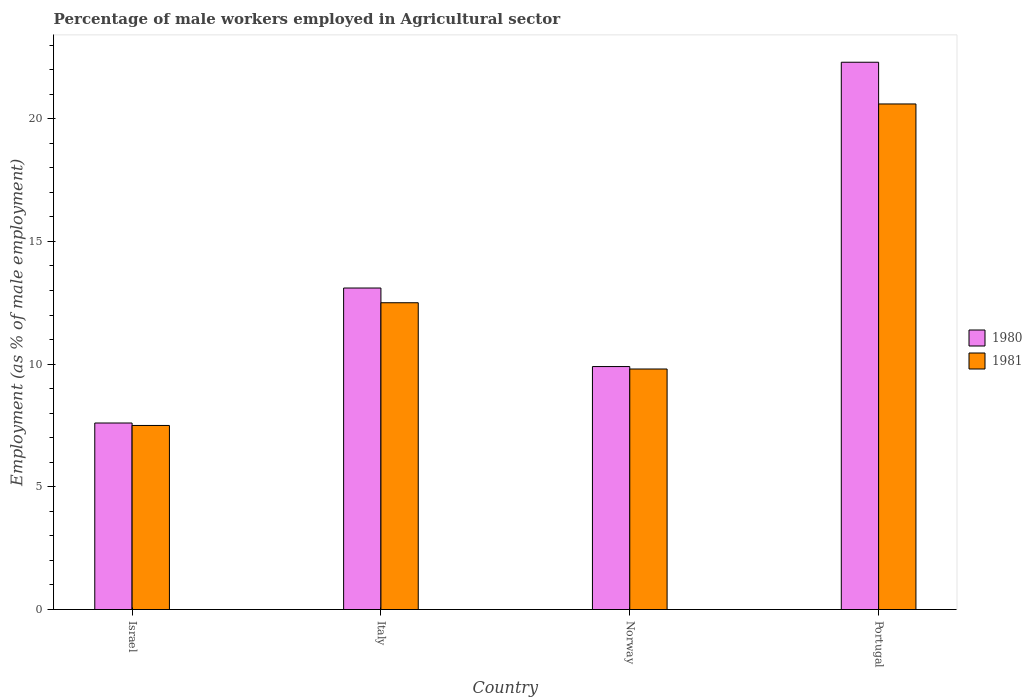How many different coloured bars are there?
Your answer should be very brief. 2. Are the number of bars per tick equal to the number of legend labels?
Provide a succinct answer. Yes. Are the number of bars on each tick of the X-axis equal?
Your response must be concise. Yes. How many bars are there on the 3rd tick from the right?
Make the answer very short. 2. In how many cases, is the number of bars for a given country not equal to the number of legend labels?
Offer a very short reply. 0. What is the percentage of male workers employed in Agricultural sector in 1980 in Norway?
Your answer should be very brief. 9.9. Across all countries, what is the maximum percentage of male workers employed in Agricultural sector in 1980?
Give a very brief answer. 22.3. In which country was the percentage of male workers employed in Agricultural sector in 1981 minimum?
Keep it short and to the point. Israel. What is the total percentage of male workers employed in Agricultural sector in 1980 in the graph?
Your answer should be compact. 52.9. What is the difference between the percentage of male workers employed in Agricultural sector in 1981 in Italy and that in Portugal?
Ensure brevity in your answer.  -8.1. What is the difference between the percentage of male workers employed in Agricultural sector in 1981 in Portugal and the percentage of male workers employed in Agricultural sector in 1980 in Norway?
Provide a succinct answer. 10.7. What is the average percentage of male workers employed in Agricultural sector in 1981 per country?
Give a very brief answer. 12.6. What is the difference between the percentage of male workers employed in Agricultural sector of/in 1981 and percentage of male workers employed in Agricultural sector of/in 1980 in Norway?
Offer a terse response. -0.1. What is the ratio of the percentage of male workers employed in Agricultural sector in 1980 in Norway to that in Portugal?
Ensure brevity in your answer.  0.44. What is the difference between the highest and the second highest percentage of male workers employed in Agricultural sector in 1981?
Provide a succinct answer. -10.8. What is the difference between the highest and the lowest percentage of male workers employed in Agricultural sector in 1980?
Your response must be concise. 14.7. What does the 1st bar from the left in Israel represents?
Keep it short and to the point. 1980. Are all the bars in the graph horizontal?
Your response must be concise. No. How many countries are there in the graph?
Provide a short and direct response. 4. Are the values on the major ticks of Y-axis written in scientific E-notation?
Offer a terse response. No. Does the graph contain any zero values?
Keep it short and to the point. No. Does the graph contain grids?
Your answer should be very brief. No. Where does the legend appear in the graph?
Your answer should be very brief. Center right. How many legend labels are there?
Ensure brevity in your answer.  2. What is the title of the graph?
Offer a very short reply. Percentage of male workers employed in Agricultural sector. Does "1978" appear as one of the legend labels in the graph?
Your response must be concise. No. What is the label or title of the Y-axis?
Your response must be concise. Employment (as % of male employment). What is the Employment (as % of male employment) in 1980 in Israel?
Offer a terse response. 7.6. What is the Employment (as % of male employment) of 1981 in Israel?
Offer a terse response. 7.5. What is the Employment (as % of male employment) of 1980 in Italy?
Give a very brief answer. 13.1. What is the Employment (as % of male employment) in 1980 in Norway?
Provide a succinct answer. 9.9. What is the Employment (as % of male employment) of 1981 in Norway?
Your response must be concise. 9.8. What is the Employment (as % of male employment) of 1980 in Portugal?
Your answer should be very brief. 22.3. What is the Employment (as % of male employment) of 1981 in Portugal?
Offer a terse response. 20.6. Across all countries, what is the maximum Employment (as % of male employment) in 1980?
Ensure brevity in your answer.  22.3. Across all countries, what is the maximum Employment (as % of male employment) in 1981?
Your answer should be very brief. 20.6. Across all countries, what is the minimum Employment (as % of male employment) of 1980?
Keep it short and to the point. 7.6. Across all countries, what is the minimum Employment (as % of male employment) of 1981?
Your answer should be very brief. 7.5. What is the total Employment (as % of male employment) of 1980 in the graph?
Your response must be concise. 52.9. What is the total Employment (as % of male employment) in 1981 in the graph?
Give a very brief answer. 50.4. What is the difference between the Employment (as % of male employment) in 1980 in Israel and that in Italy?
Provide a succinct answer. -5.5. What is the difference between the Employment (as % of male employment) of 1981 in Israel and that in Norway?
Provide a short and direct response. -2.3. What is the difference between the Employment (as % of male employment) of 1980 in Israel and that in Portugal?
Provide a short and direct response. -14.7. What is the difference between the Employment (as % of male employment) in 1981 in Italy and that in Norway?
Your answer should be compact. 2.7. What is the difference between the Employment (as % of male employment) of 1980 in Norway and that in Portugal?
Provide a succinct answer. -12.4. What is the difference between the Employment (as % of male employment) of 1981 in Norway and that in Portugal?
Keep it short and to the point. -10.8. What is the difference between the Employment (as % of male employment) in 1980 in Israel and the Employment (as % of male employment) in 1981 in Italy?
Make the answer very short. -4.9. What is the difference between the Employment (as % of male employment) in 1980 in Italy and the Employment (as % of male employment) in 1981 in Norway?
Give a very brief answer. 3.3. What is the difference between the Employment (as % of male employment) of 1980 in Norway and the Employment (as % of male employment) of 1981 in Portugal?
Offer a very short reply. -10.7. What is the average Employment (as % of male employment) of 1980 per country?
Your answer should be very brief. 13.22. What is the difference between the Employment (as % of male employment) in 1980 and Employment (as % of male employment) in 1981 in Italy?
Make the answer very short. 0.6. What is the difference between the Employment (as % of male employment) in 1980 and Employment (as % of male employment) in 1981 in Norway?
Your answer should be compact. 0.1. What is the difference between the Employment (as % of male employment) of 1980 and Employment (as % of male employment) of 1981 in Portugal?
Your answer should be very brief. 1.7. What is the ratio of the Employment (as % of male employment) of 1980 in Israel to that in Italy?
Provide a succinct answer. 0.58. What is the ratio of the Employment (as % of male employment) of 1981 in Israel to that in Italy?
Offer a terse response. 0.6. What is the ratio of the Employment (as % of male employment) in 1980 in Israel to that in Norway?
Your answer should be compact. 0.77. What is the ratio of the Employment (as % of male employment) of 1981 in Israel to that in Norway?
Offer a terse response. 0.77. What is the ratio of the Employment (as % of male employment) in 1980 in Israel to that in Portugal?
Make the answer very short. 0.34. What is the ratio of the Employment (as % of male employment) of 1981 in Israel to that in Portugal?
Provide a succinct answer. 0.36. What is the ratio of the Employment (as % of male employment) in 1980 in Italy to that in Norway?
Keep it short and to the point. 1.32. What is the ratio of the Employment (as % of male employment) in 1981 in Italy to that in Norway?
Offer a very short reply. 1.28. What is the ratio of the Employment (as % of male employment) in 1980 in Italy to that in Portugal?
Make the answer very short. 0.59. What is the ratio of the Employment (as % of male employment) of 1981 in Italy to that in Portugal?
Your answer should be compact. 0.61. What is the ratio of the Employment (as % of male employment) in 1980 in Norway to that in Portugal?
Provide a succinct answer. 0.44. What is the ratio of the Employment (as % of male employment) of 1981 in Norway to that in Portugal?
Give a very brief answer. 0.48. What is the difference between the highest and the second highest Employment (as % of male employment) in 1981?
Ensure brevity in your answer.  8.1. What is the difference between the highest and the lowest Employment (as % of male employment) in 1981?
Give a very brief answer. 13.1. 